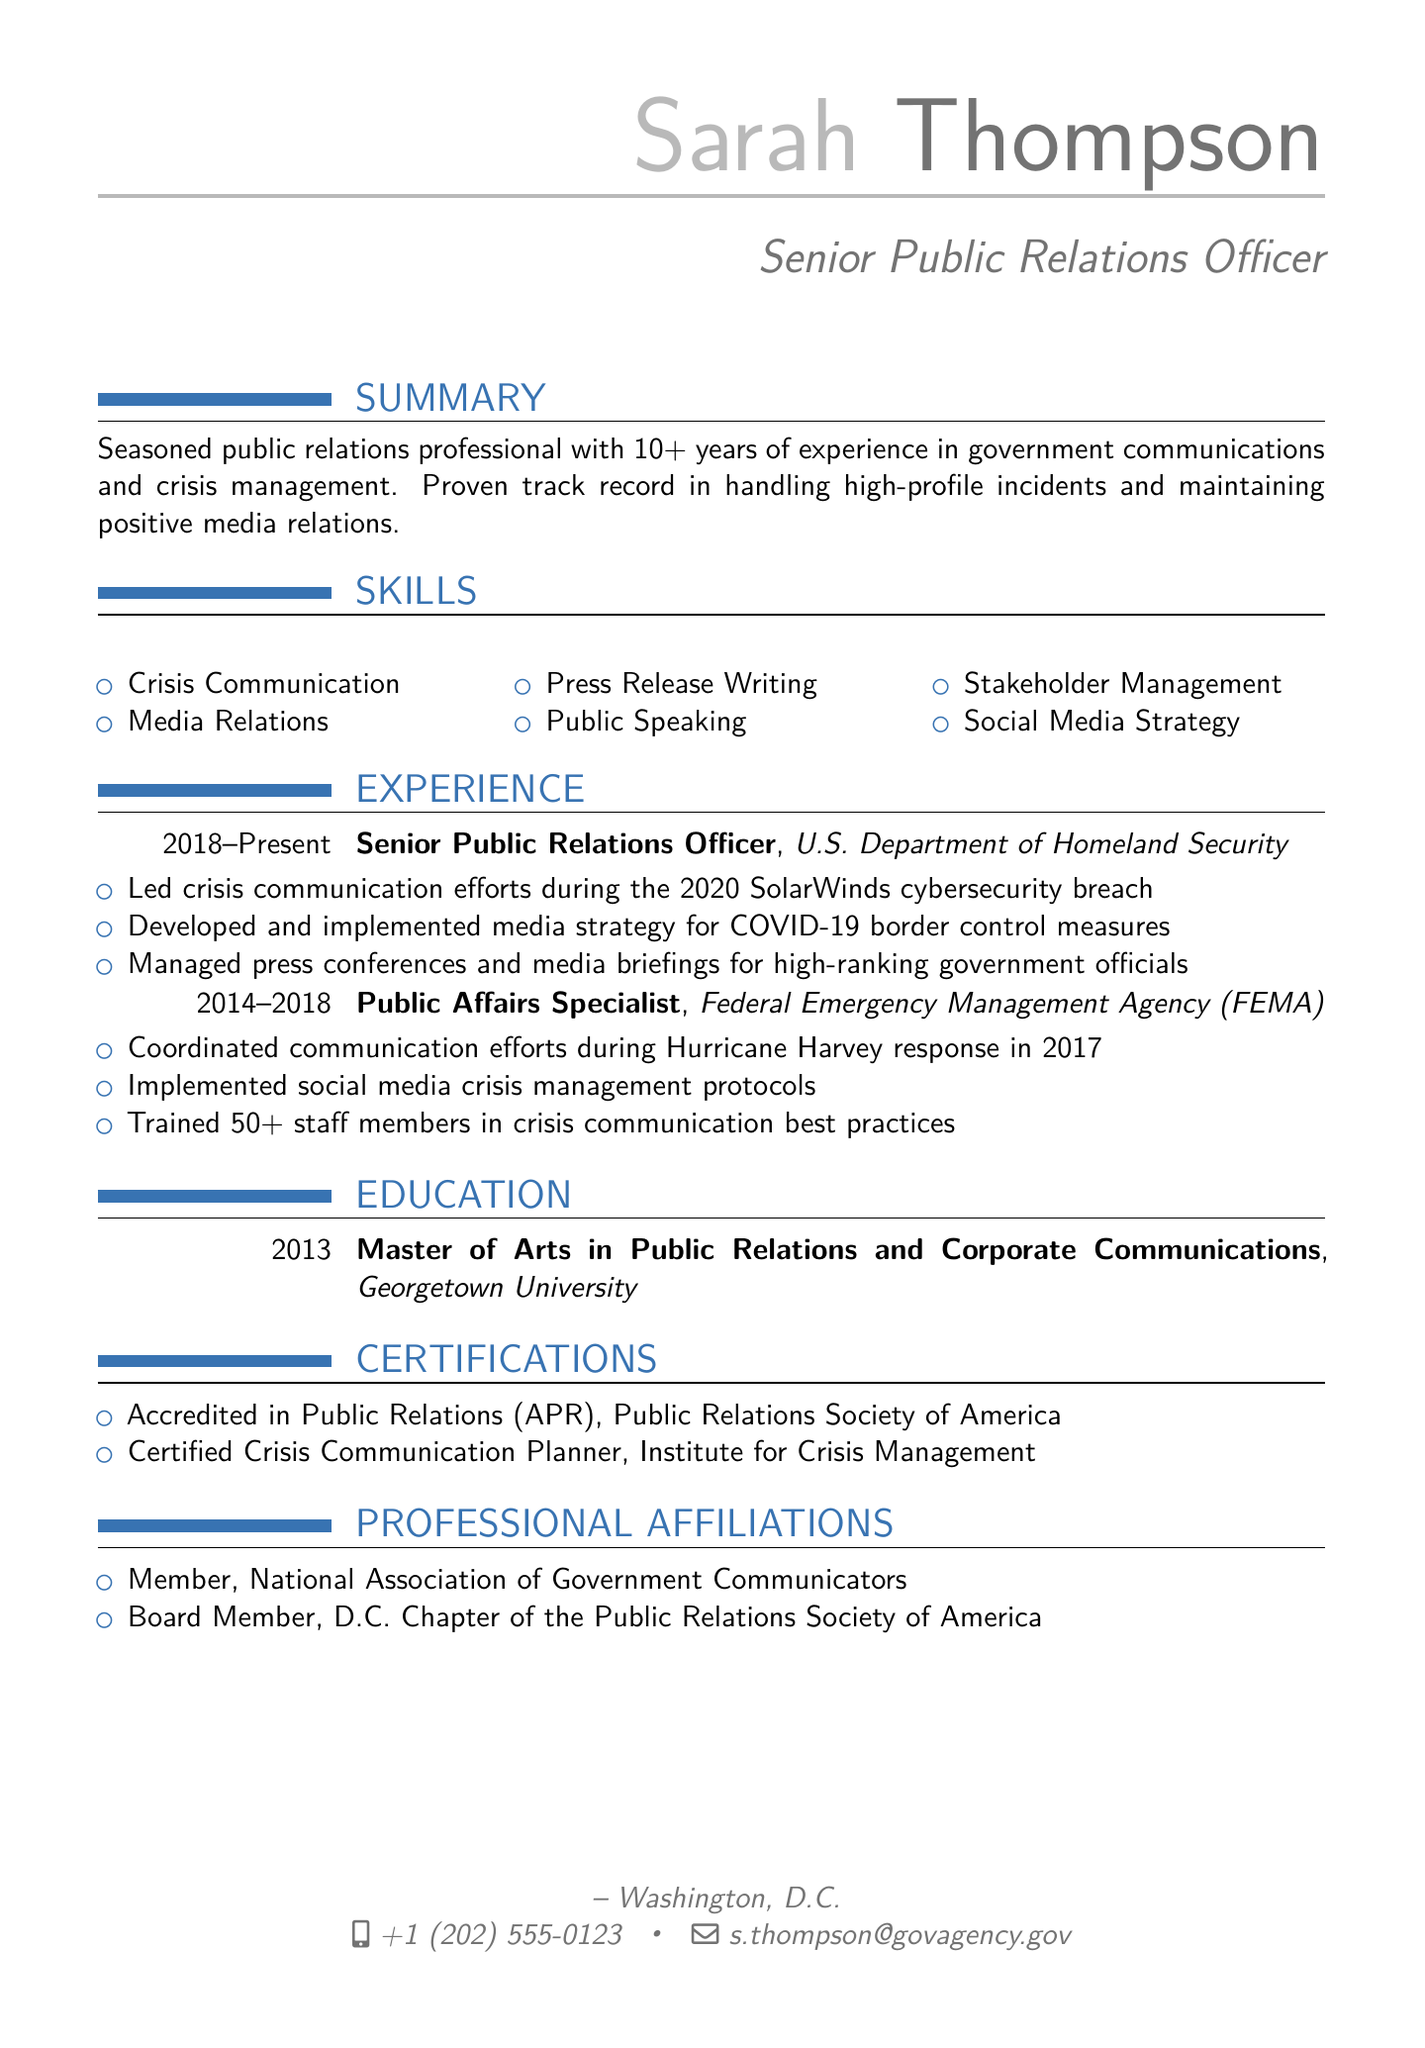What is Sarah Thompson's title? The title is specified under personal information, indicating her professional role within the government agency.
Answer: Senior Public Relations Officer What organization does Sarah currently work for? This information is detailed in the experience section, specifying her current employment.
Answer: U.S. Department of Homeland Security During which incident did Sarah lead crisis communication efforts? The experience section lists her involvement in significant events, giving context to her crisis management role.
Answer: 2020 SolarWinds cybersecurity breach How many years of experience does Sarah have in public relations? The summary quantifies her professional experience within the field as stated at the beginning of the document.
Answer: 10+ What degree did Sarah earn, and from which institution? The education section provides details on her academic qualifications and the institution she attended.
Answer: Master of Arts in Public Relations and Corporate Communications, Georgetown University How many staff members did Sarah train in crisis communication best practices? This detail is found under her achievements at FEMA and reflects her role in capacity building within the agency.
Answer: 50+ Which professional organization is Sarah a member of? The professional affiliations section highlights her involvement in significant professional groups in public relations.
Answer: National Association of Government Communicators What certification does Sarah hold related to crisis communication? Certification details in the document outline her qualifications, particularly those relevant to her role in crisis management.
Answer: Certified Crisis Communication Planner 